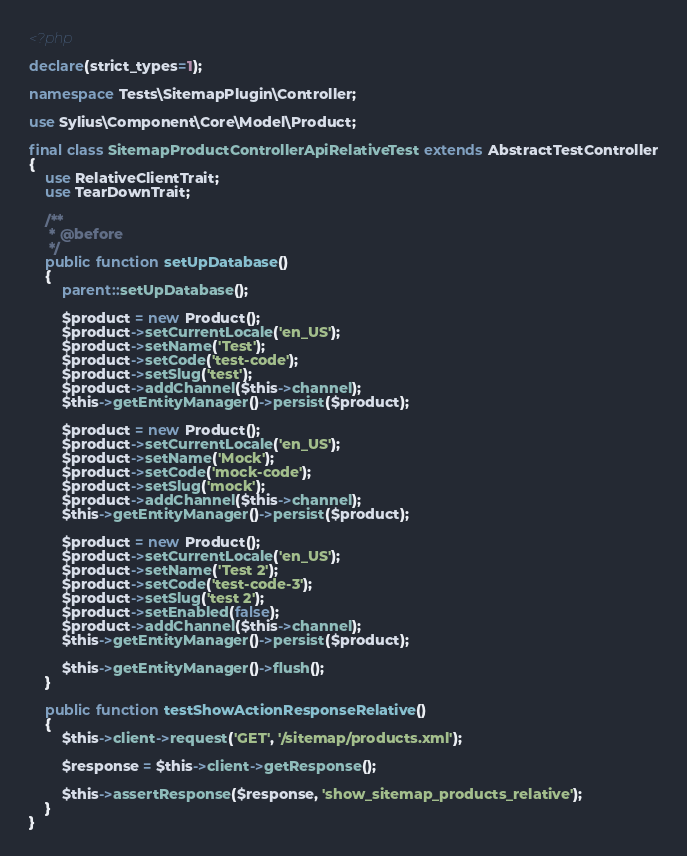Convert code to text. <code><loc_0><loc_0><loc_500><loc_500><_PHP_><?php

declare(strict_types=1);

namespace Tests\SitemapPlugin\Controller;

use Sylius\Component\Core\Model\Product;

final class SitemapProductControllerApiRelativeTest extends AbstractTestController
{
    use RelativeClientTrait;
    use TearDownTrait;

    /**
     * @before
     */
    public function setUpDatabase()
    {
        parent::setUpDatabase();

        $product = new Product();
        $product->setCurrentLocale('en_US');
        $product->setName('Test');
        $product->setCode('test-code');
        $product->setSlug('test');
        $product->addChannel($this->channel);
        $this->getEntityManager()->persist($product);

        $product = new Product();
        $product->setCurrentLocale('en_US');
        $product->setName('Mock');
        $product->setCode('mock-code');
        $product->setSlug('mock');
        $product->addChannel($this->channel);
        $this->getEntityManager()->persist($product);

        $product = new Product();
        $product->setCurrentLocale('en_US');
        $product->setName('Test 2');
        $product->setCode('test-code-3');
        $product->setSlug('test 2');
        $product->setEnabled(false);
        $product->addChannel($this->channel);
        $this->getEntityManager()->persist($product);

        $this->getEntityManager()->flush();
    }

    public function testShowActionResponseRelative()
    {
        $this->client->request('GET', '/sitemap/products.xml');

        $response = $this->client->getResponse();

        $this->assertResponse($response, 'show_sitemap_products_relative');
    }
}
</code> 